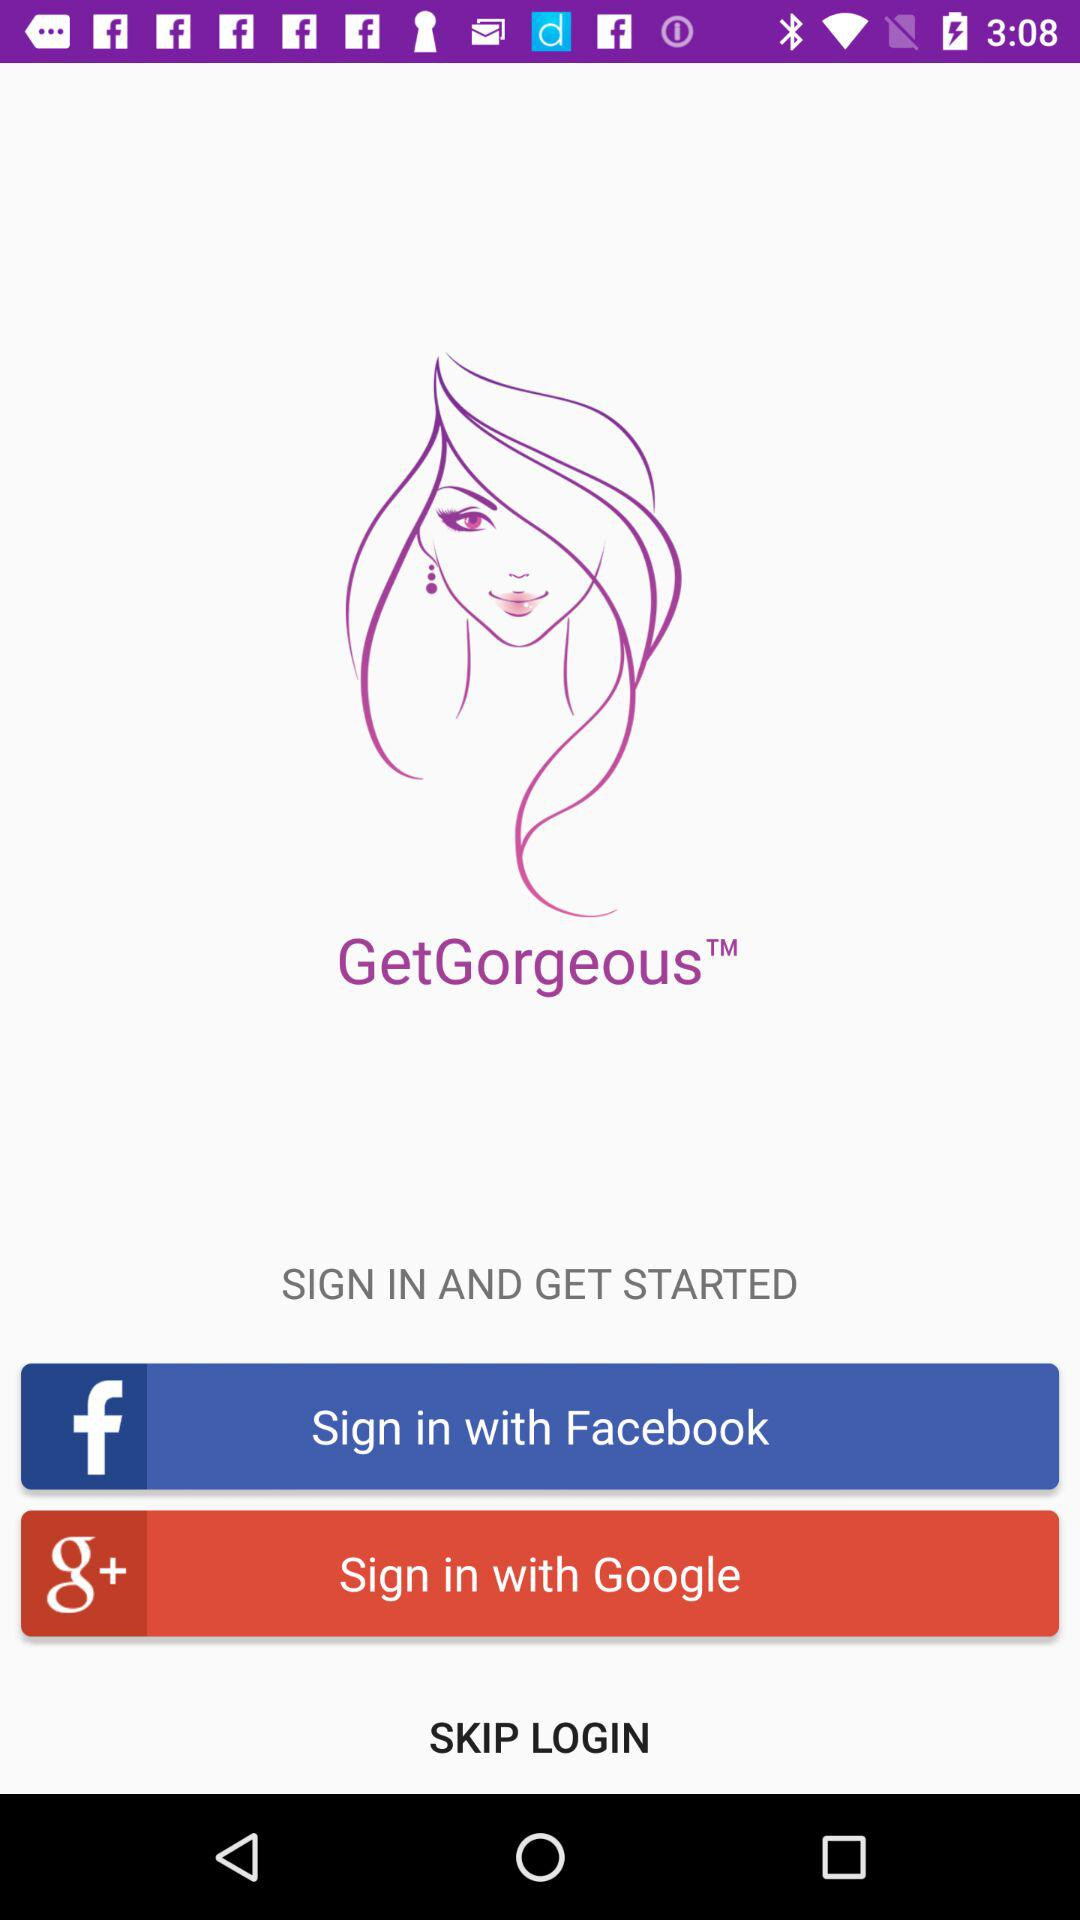How many sign in options are there?
Answer the question using a single word or phrase. 2 